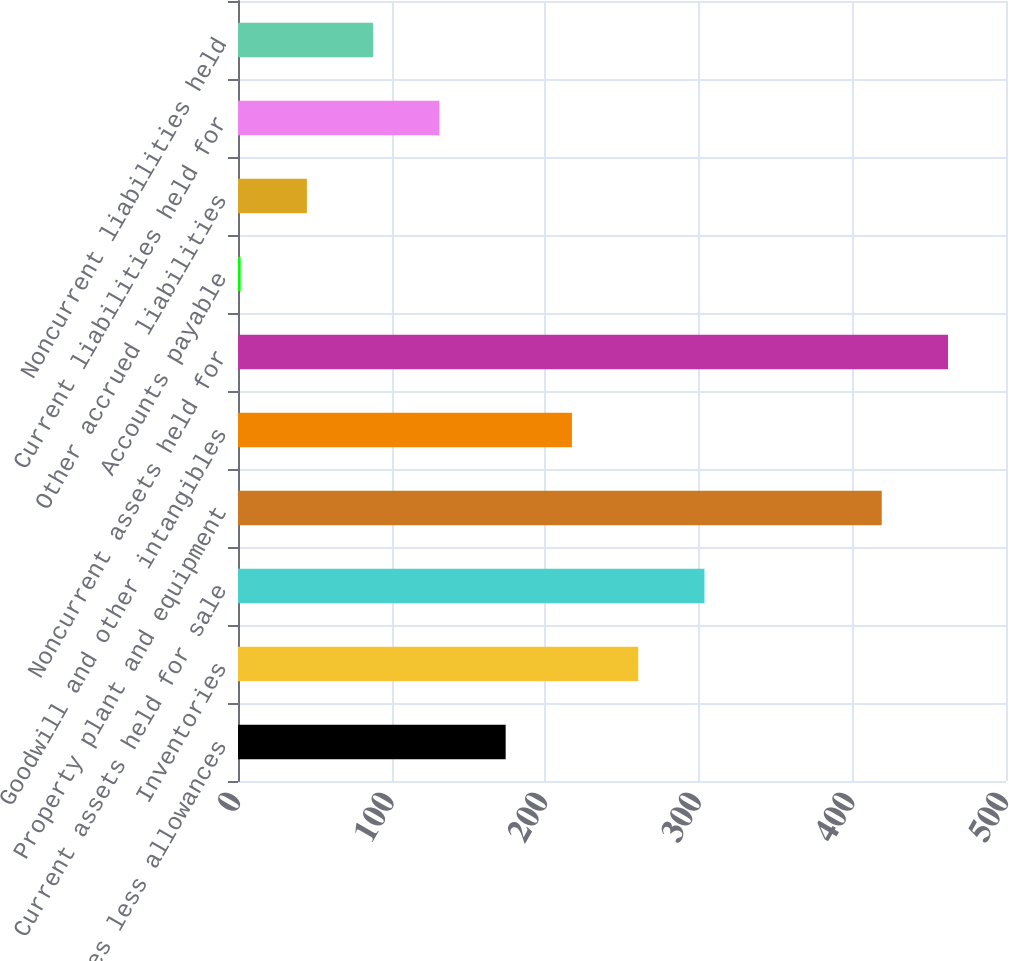Convert chart to OTSL. <chart><loc_0><loc_0><loc_500><loc_500><bar_chart><fcel>Receivables less allowances<fcel>Inventories<fcel>Current assets held for sale<fcel>Property plant and equipment<fcel>Goodwill and other intangibles<fcel>Noncurrent assets held for<fcel>Accounts payable<fcel>Other accrued liabilities<fcel>Current liabilities held for<fcel>Noncurrent liabilities held<nl><fcel>174.26<fcel>260.54<fcel>303.68<fcel>419.1<fcel>217.4<fcel>462.24<fcel>1.7<fcel>44.84<fcel>131.12<fcel>87.98<nl></chart> 